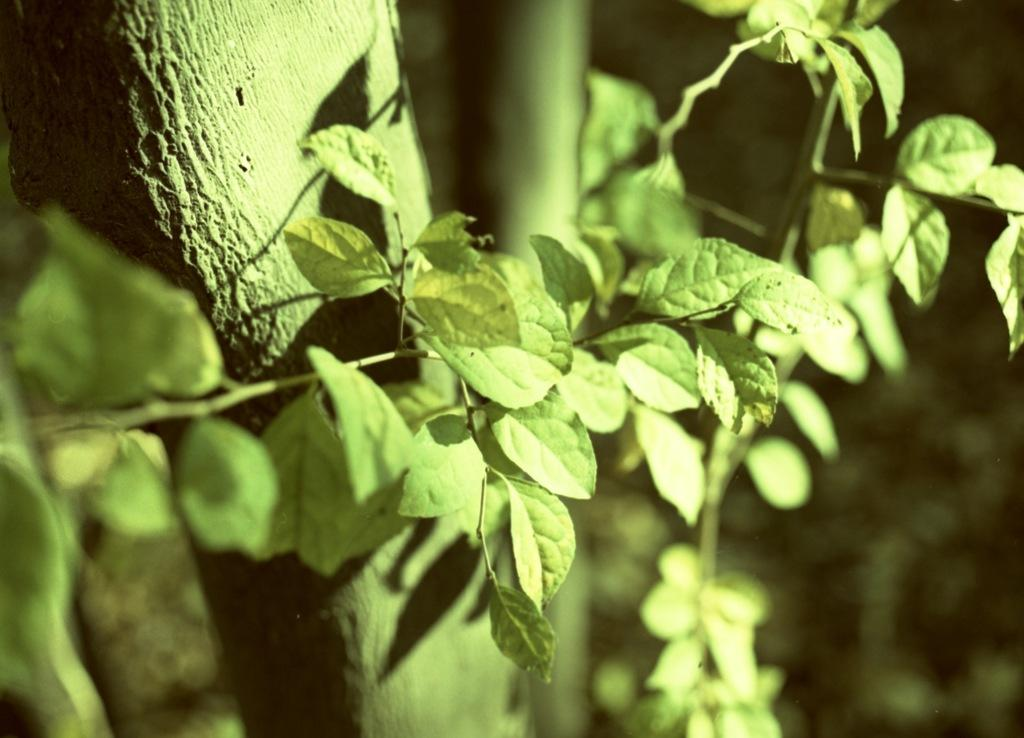What type of environment is depicted in the image? The image contains greenery, suggesting a natural or outdoor setting. Can you describe the background of the image? The background of the image is blurry, which may indicate a shallow depth of field or a focus on a specific subject in the foreground. What type of insect can be seen biting the office chair in the image? There is no insect or office chair present in the image. 